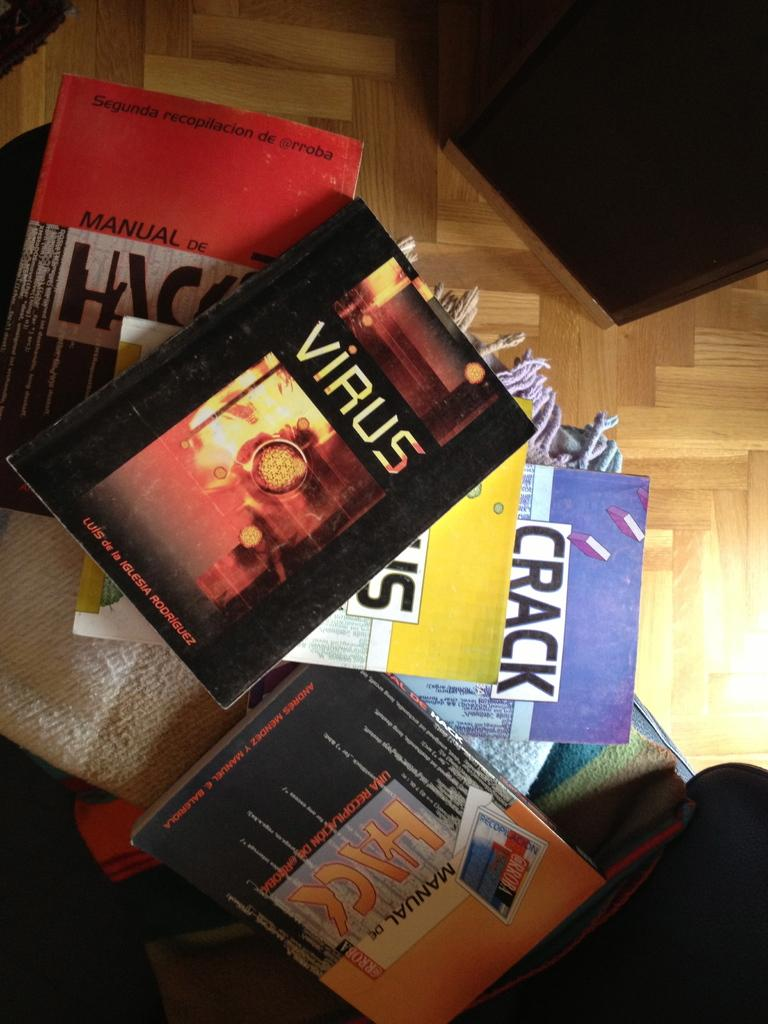<image>
Describe the image concisely. Several books together including the title Virus, and Crack. 